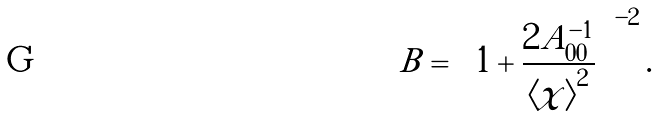<formula> <loc_0><loc_0><loc_500><loc_500>B = \left ( 1 + \frac { 2 A _ { 0 0 } ^ { - 1 } } { \left \langle \chi \right \rangle ^ { 2 } } \right ) ^ { - 2 } .</formula> 